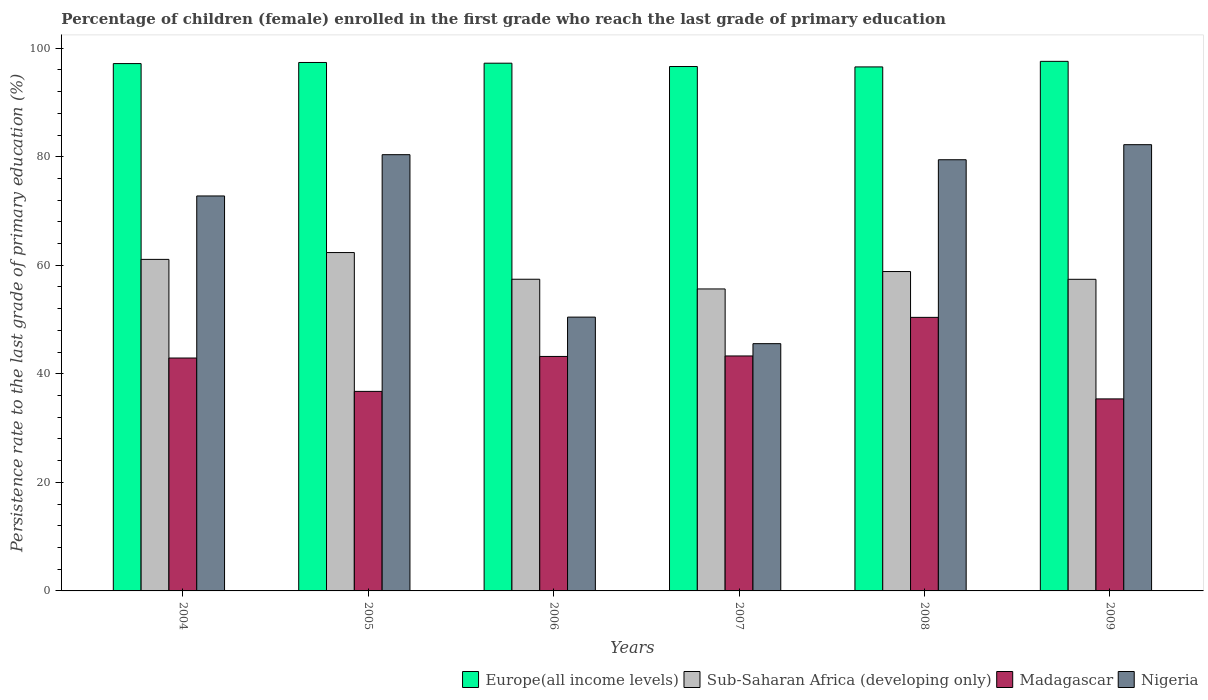How many different coloured bars are there?
Provide a succinct answer. 4. Are the number of bars on each tick of the X-axis equal?
Provide a succinct answer. Yes. What is the persistence rate of children in Sub-Saharan Africa (developing only) in 2009?
Provide a short and direct response. 57.41. Across all years, what is the maximum persistence rate of children in Europe(all income levels)?
Give a very brief answer. 97.57. Across all years, what is the minimum persistence rate of children in Sub-Saharan Africa (developing only)?
Your answer should be compact. 55.64. In which year was the persistence rate of children in Nigeria minimum?
Offer a terse response. 2007. What is the total persistence rate of children in Sub-Saharan Africa (developing only) in the graph?
Your answer should be very brief. 352.75. What is the difference between the persistence rate of children in Sub-Saharan Africa (developing only) in 2004 and that in 2009?
Make the answer very short. 3.67. What is the difference between the persistence rate of children in Europe(all income levels) in 2007 and the persistence rate of children in Nigeria in 2005?
Ensure brevity in your answer.  16.24. What is the average persistence rate of children in Sub-Saharan Africa (developing only) per year?
Make the answer very short. 58.79. In the year 2008, what is the difference between the persistence rate of children in Sub-Saharan Africa (developing only) and persistence rate of children in Nigeria?
Offer a very short reply. -20.6. What is the ratio of the persistence rate of children in Europe(all income levels) in 2005 to that in 2007?
Your response must be concise. 1.01. Is the persistence rate of children in Sub-Saharan Africa (developing only) in 2004 less than that in 2008?
Your response must be concise. No. Is the difference between the persistence rate of children in Sub-Saharan Africa (developing only) in 2005 and 2008 greater than the difference between the persistence rate of children in Nigeria in 2005 and 2008?
Your response must be concise. Yes. What is the difference between the highest and the second highest persistence rate of children in Europe(all income levels)?
Keep it short and to the point. 0.21. What is the difference between the highest and the lowest persistence rate of children in Sub-Saharan Africa (developing only)?
Provide a succinct answer. 6.71. In how many years, is the persistence rate of children in Nigeria greater than the average persistence rate of children in Nigeria taken over all years?
Keep it short and to the point. 4. Is the sum of the persistence rate of children in Europe(all income levels) in 2004 and 2008 greater than the maximum persistence rate of children in Nigeria across all years?
Ensure brevity in your answer.  Yes. Is it the case that in every year, the sum of the persistence rate of children in Madagascar and persistence rate of children in Europe(all income levels) is greater than the sum of persistence rate of children in Nigeria and persistence rate of children in Sub-Saharan Africa (developing only)?
Give a very brief answer. No. What does the 2nd bar from the left in 2004 represents?
Keep it short and to the point. Sub-Saharan Africa (developing only). What does the 1st bar from the right in 2006 represents?
Your answer should be compact. Nigeria. Is it the case that in every year, the sum of the persistence rate of children in Sub-Saharan Africa (developing only) and persistence rate of children in Nigeria is greater than the persistence rate of children in Madagascar?
Provide a succinct answer. Yes. How many bars are there?
Keep it short and to the point. 24. How many years are there in the graph?
Your answer should be compact. 6. What is the difference between two consecutive major ticks on the Y-axis?
Your response must be concise. 20. Are the values on the major ticks of Y-axis written in scientific E-notation?
Make the answer very short. No. Does the graph contain any zero values?
Give a very brief answer. No. How are the legend labels stacked?
Keep it short and to the point. Horizontal. What is the title of the graph?
Give a very brief answer. Percentage of children (female) enrolled in the first grade who reach the last grade of primary education. Does "Kuwait" appear as one of the legend labels in the graph?
Ensure brevity in your answer.  No. What is the label or title of the X-axis?
Provide a succinct answer. Years. What is the label or title of the Y-axis?
Give a very brief answer. Persistence rate to the last grade of primary education (%). What is the Persistence rate to the last grade of primary education (%) in Europe(all income levels) in 2004?
Your answer should be very brief. 97.16. What is the Persistence rate to the last grade of primary education (%) of Sub-Saharan Africa (developing only) in 2004?
Your response must be concise. 61.08. What is the Persistence rate to the last grade of primary education (%) of Madagascar in 2004?
Provide a short and direct response. 42.91. What is the Persistence rate to the last grade of primary education (%) in Nigeria in 2004?
Ensure brevity in your answer.  72.77. What is the Persistence rate to the last grade of primary education (%) of Europe(all income levels) in 2005?
Keep it short and to the point. 97.36. What is the Persistence rate to the last grade of primary education (%) of Sub-Saharan Africa (developing only) in 2005?
Offer a terse response. 62.34. What is the Persistence rate to the last grade of primary education (%) of Madagascar in 2005?
Ensure brevity in your answer.  36.77. What is the Persistence rate to the last grade of primary education (%) in Nigeria in 2005?
Provide a short and direct response. 80.38. What is the Persistence rate to the last grade of primary education (%) in Europe(all income levels) in 2006?
Keep it short and to the point. 97.23. What is the Persistence rate to the last grade of primary education (%) of Sub-Saharan Africa (developing only) in 2006?
Offer a very short reply. 57.43. What is the Persistence rate to the last grade of primary education (%) of Madagascar in 2006?
Provide a short and direct response. 43.2. What is the Persistence rate to the last grade of primary education (%) of Nigeria in 2006?
Offer a terse response. 50.45. What is the Persistence rate to the last grade of primary education (%) of Europe(all income levels) in 2007?
Ensure brevity in your answer.  96.62. What is the Persistence rate to the last grade of primary education (%) of Sub-Saharan Africa (developing only) in 2007?
Your answer should be compact. 55.64. What is the Persistence rate to the last grade of primary education (%) in Madagascar in 2007?
Provide a succinct answer. 43.29. What is the Persistence rate to the last grade of primary education (%) of Nigeria in 2007?
Your answer should be very brief. 45.56. What is the Persistence rate to the last grade of primary education (%) of Europe(all income levels) in 2008?
Provide a short and direct response. 96.55. What is the Persistence rate to the last grade of primary education (%) in Sub-Saharan Africa (developing only) in 2008?
Offer a very short reply. 58.85. What is the Persistence rate to the last grade of primary education (%) in Madagascar in 2008?
Offer a very short reply. 50.4. What is the Persistence rate to the last grade of primary education (%) in Nigeria in 2008?
Provide a short and direct response. 79.44. What is the Persistence rate to the last grade of primary education (%) in Europe(all income levels) in 2009?
Offer a very short reply. 97.57. What is the Persistence rate to the last grade of primary education (%) in Sub-Saharan Africa (developing only) in 2009?
Your answer should be compact. 57.41. What is the Persistence rate to the last grade of primary education (%) of Madagascar in 2009?
Provide a succinct answer. 35.38. What is the Persistence rate to the last grade of primary education (%) of Nigeria in 2009?
Keep it short and to the point. 82.22. Across all years, what is the maximum Persistence rate to the last grade of primary education (%) of Europe(all income levels)?
Offer a terse response. 97.57. Across all years, what is the maximum Persistence rate to the last grade of primary education (%) in Sub-Saharan Africa (developing only)?
Your answer should be compact. 62.34. Across all years, what is the maximum Persistence rate to the last grade of primary education (%) of Madagascar?
Give a very brief answer. 50.4. Across all years, what is the maximum Persistence rate to the last grade of primary education (%) of Nigeria?
Your response must be concise. 82.22. Across all years, what is the minimum Persistence rate to the last grade of primary education (%) of Europe(all income levels)?
Your response must be concise. 96.55. Across all years, what is the minimum Persistence rate to the last grade of primary education (%) of Sub-Saharan Africa (developing only)?
Your response must be concise. 55.64. Across all years, what is the minimum Persistence rate to the last grade of primary education (%) in Madagascar?
Your answer should be very brief. 35.38. Across all years, what is the minimum Persistence rate to the last grade of primary education (%) of Nigeria?
Provide a short and direct response. 45.56. What is the total Persistence rate to the last grade of primary education (%) in Europe(all income levels) in the graph?
Offer a very short reply. 582.49. What is the total Persistence rate to the last grade of primary education (%) of Sub-Saharan Africa (developing only) in the graph?
Your answer should be compact. 352.75. What is the total Persistence rate to the last grade of primary education (%) in Madagascar in the graph?
Make the answer very short. 251.95. What is the total Persistence rate to the last grade of primary education (%) of Nigeria in the graph?
Keep it short and to the point. 410.82. What is the difference between the Persistence rate to the last grade of primary education (%) in Europe(all income levels) in 2004 and that in 2005?
Keep it short and to the point. -0.2. What is the difference between the Persistence rate to the last grade of primary education (%) of Sub-Saharan Africa (developing only) in 2004 and that in 2005?
Make the answer very short. -1.26. What is the difference between the Persistence rate to the last grade of primary education (%) of Madagascar in 2004 and that in 2005?
Provide a succinct answer. 6.15. What is the difference between the Persistence rate to the last grade of primary education (%) in Nigeria in 2004 and that in 2005?
Offer a terse response. -7.61. What is the difference between the Persistence rate to the last grade of primary education (%) in Europe(all income levels) in 2004 and that in 2006?
Your response must be concise. -0.07. What is the difference between the Persistence rate to the last grade of primary education (%) in Sub-Saharan Africa (developing only) in 2004 and that in 2006?
Offer a terse response. 3.66. What is the difference between the Persistence rate to the last grade of primary education (%) of Madagascar in 2004 and that in 2006?
Give a very brief answer. -0.29. What is the difference between the Persistence rate to the last grade of primary education (%) of Nigeria in 2004 and that in 2006?
Provide a short and direct response. 22.32. What is the difference between the Persistence rate to the last grade of primary education (%) in Europe(all income levels) in 2004 and that in 2007?
Your answer should be compact. 0.54. What is the difference between the Persistence rate to the last grade of primary education (%) in Sub-Saharan Africa (developing only) in 2004 and that in 2007?
Offer a terse response. 5.45. What is the difference between the Persistence rate to the last grade of primary education (%) of Madagascar in 2004 and that in 2007?
Your answer should be compact. -0.38. What is the difference between the Persistence rate to the last grade of primary education (%) in Nigeria in 2004 and that in 2007?
Give a very brief answer. 27.21. What is the difference between the Persistence rate to the last grade of primary education (%) of Europe(all income levels) in 2004 and that in 2008?
Offer a terse response. 0.61. What is the difference between the Persistence rate to the last grade of primary education (%) of Sub-Saharan Africa (developing only) in 2004 and that in 2008?
Offer a terse response. 2.24. What is the difference between the Persistence rate to the last grade of primary education (%) of Madagascar in 2004 and that in 2008?
Make the answer very short. -7.49. What is the difference between the Persistence rate to the last grade of primary education (%) in Nigeria in 2004 and that in 2008?
Offer a terse response. -6.67. What is the difference between the Persistence rate to the last grade of primary education (%) of Europe(all income levels) in 2004 and that in 2009?
Give a very brief answer. -0.41. What is the difference between the Persistence rate to the last grade of primary education (%) in Sub-Saharan Africa (developing only) in 2004 and that in 2009?
Ensure brevity in your answer.  3.67. What is the difference between the Persistence rate to the last grade of primary education (%) in Madagascar in 2004 and that in 2009?
Offer a very short reply. 7.53. What is the difference between the Persistence rate to the last grade of primary education (%) in Nigeria in 2004 and that in 2009?
Make the answer very short. -9.45. What is the difference between the Persistence rate to the last grade of primary education (%) of Europe(all income levels) in 2005 and that in 2006?
Offer a terse response. 0.13. What is the difference between the Persistence rate to the last grade of primary education (%) in Sub-Saharan Africa (developing only) in 2005 and that in 2006?
Ensure brevity in your answer.  4.92. What is the difference between the Persistence rate to the last grade of primary education (%) in Madagascar in 2005 and that in 2006?
Provide a short and direct response. -6.43. What is the difference between the Persistence rate to the last grade of primary education (%) of Nigeria in 2005 and that in 2006?
Your answer should be compact. 29.93. What is the difference between the Persistence rate to the last grade of primary education (%) in Europe(all income levels) in 2005 and that in 2007?
Ensure brevity in your answer.  0.75. What is the difference between the Persistence rate to the last grade of primary education (%) in Sub-Saharan Africa (developing only) in 2005 and that in 2007?
Give a very brief answer. 6.71. What is the difference between the Persistence rate to the last grade of primary education (%) of Madagascar in 2005 and that in 2007?
Provide a short and direct response. -6.53. What is the difference between the Persistence rate to the last grade of primary education (%) in Nigeria in 2005 and that in 2007?
Make the answer very short. 34.82. What is the difference between the Persistence rate to the last grade of primary education (%) in Europe(all income levels) in 2005 and that in 2008?
Make the answer very short. 0.82. What is the difference between the Persistence rate to the last grade of primary education (%) in Sub-Saharan Africa (developing only) in 2005 and that in 2008?
Offer a very short reply. 3.5. What is the difference between the Persistence rate to the last grade of primary education (%) in Madagascar in 2005 and that in 2008?
Ensure brevity in your answer.  -13.64. What is the difference between the Persistence rate to the last grade of primary education (%) in Nigeria in 2005 and that in 2008?
Your response must be concise. 0.93. What is the difference between the Persistence rate to the last grade of primary education (%) of Europe(all income levels) in 2005 and that in 2009?
Make the answer very short. -0.21. What is the difference between the Persistence rate to the last grade of primary education (%) in Sub-Saharan Africa (developing only) in 2005 and that in 2009?
Your answer should be very brief. 4.93. What is the difference between the Persistence rate to the last grade of primary education (%) in Madagascar in 2005 and that in 2009?
Give a very brief answer. 1.39. What is the difference between the Persistence rate to the last grade of primary education (%) of Nigeria in 2005 and that in 2009?
Give a very brief answer. -1.84. What is the difference between the Persistence rate to the last grade of primary education (%) of Europe(all income levels) in 2006 and that in 2007?
Ensure brevity in your answer.  0.61. What is the difference between the Persistence rate to the last grade of primary education (%) of Sub-Saharan Africa (developing only) in 2006 and that in 2007?
Give a very brief answer. 1.79. What is the difference between the Persistence rate to the last grade of primary education (%) of Madagascar in 2006 and that in 2007?
Offer a very short reply. -0.09. What is the difference between the Persistence rate to the last grade of primary education (%) of Nigeria in 2006 and that in 2007?
Your answer should be very brief. 4.89. What is the difference between the Persistence rate to the last grade of primary education (%) in Europe(all income levels) in 2006 and that in 2008?
Your answer should be compact. 0.68. What is the difference between the Persistence rate to the last grade of primary education (%) of Sub-Saharan Africa (developing only) in 2006 and that in 2008?
Your response must be concise. -1.42. What is the difference between the Persistence rate to the last grade of primary education (%) of Madagascar in 2006 and that in 2008?
Offer a terse response. -7.2. What is the difference between the Persistence rate to the last grade of primary education (%) in Nigeria in 2006 and that in 2008?
Offer a very short reply. -29. What is the difference between the Persistence rate to the last grade of primary education (%) in Europe(all income levels) in 2006 and that in 2009?
Ensure brevity in your answer.  -0.34. What is the difference between the Persistence rate to the last grade of primary education (%) of Sub-Saharan Africa (developing only) in 2006 and that in 2009?
Your answer should be very brief. 0.01. What is the difference between the Persistence rate to the last grade of primary education (%) in Madagascar in 2006 and that in 2009?
Offer a terse response. 7.82. What is the difference between the Persistence rate to the last grade of primary education (%) in Nigeria in 2006 and that in 2009?
Provide a short and direct response. -31.77. What is the difference between the Persistence rate to the last grade of primary education (%) of Europe(all income levels) in 2007 and that in 2008?
Make the answer very short. 0.07. What is the difference between the Persistence rate to the last grade of primary education (%) in Sub-Saharan Africa (developing only) in 2007 and that in 2008?
Give a very brief answer. -3.21. What is the difference between the Persistence rate to the last grade of primary education (%) in Madagascar in 2007 and that in 2008?
Your answer should be very brief. -7.11. What is the difference between the Persistence rate to the last grade of primary education (%) in Nigeria in 2007 and that in 2008?
Keep it short and to the point. -33.89. What is the difference between the Persistence rate to the last grade of primary education (%) in Europe(all income levels) in 2007 and that in 2009?
Keep it short and to the point. -0.95. What is the difference between the Persistence rate to the last grade of primary education (%) of Sub-Saharan Africa (developing only) in 2007 and that in 2009?
Your answer should be compact. -1.78. What is the difference between the Persistence rate to the last grade of primary education (%) of Madagascar in 2007 and that in 2009?
Your answer should be compact. 7.91. What is the difference between the Persistence rate to the last grade of primary education (%) of Nigeria in 2007 and that in 2009?
Offer a terse response. -36.66. What is the difference between the Persistence rate to the last grade of primary education (%) in Europe(all income levels) in 2008 and that in 2009?
Provide a succinct answer. -1.02. What is the difference between the Persistence rate to the last grade of primary education (%) in Sub-Saharan Africa (developing only) in 2008 and that in 2009?
Offer a terse response. 1.43. What is the difference between the Persistence rate to the last grade of primary education (%) of Madagascar in 2008 and that in 2009?
Provide a succinct answer. 15.02. What is the difference between the Persistence rate to the last grade of primary education (%) in Nigeria in 2008 and that in 2009?
Make the answer very short. -2.77. What is the difference between the Persistence rate to the last grade of primary education (%) of Europe(all income levels) in 2004 and the Persistence rate to the last grade of primary education (%) of Sub-Saharan Africa (developing only) in 2005?
Your answer should be compact. 34.82. What is the difference between the Persistence rate to the last grade of primary education (%) in Europe(all income levels) in 2004 and the Persistence rate to the last grade of primary education (%) in Madagascar in 2005?
Offer a terse response. 60.4. What is the difference between the Persistence rate to the last grade of primary education (%) in Europe(all income levels) in 2004 and the Persistence rate to the last grade of primary education (%) in Nigeria in 2005?
Your answer should be compact. 16.78. What is the difference between the Persistence rate to the last grade of primary education (%) in Sub-Saharan Africa (developing only) in 2004 and the Persistence rate to the last grade of primary education (%) in Madagascar in 2005?
Provide a short and direct response. 24.32. What is the difference between the Persistence rate to the last grade of primary education (%) in Sub-Saharan Africa (developing only) in 2004 and the Persistence rate to the last grade of primary education (%) in Nigeria in 2005?
Provide a short and direct response. -19.29. What is the difference between the Persistence rate to the last grade of primary education (%) in Madagascar in 2004 and the Persistence rate to the last grade of primary education (%) in Nigeria in 2005?
Offer a very short reply. -37.47. What is the difference between the Persistence rate to the last grade of primary education (%) in Europe(all income levels) in 2004 and the Persistence rate to the last grade of primary education (%) in Sub-Saharan Africa (developing only) in 2006?
Ensure brevity in your answer.  39.74. What is the difference between the Persistence rate to the last grade of primary education (%) in Europe(all income levels) in 2004 and the Persistence rate to the last grade of primary education (%) in Madagascar in 2006?
Offer a very short reply. 53.96. What is the difference between the Persistence rate to the last grade of primary education (%) in Europe(all income levels) in 2004 and the Persistence rate to the last grade of primary education (%) in Nigeria in 2006?
Make the answer very short. 46.71. What is the difference between the Persistence rate to the last grade of primary education (%) of Sub-Saharan Africa (developing only) in 2004 and the Persistence rate to the last grade of primary education (%) of Madagascar in 2006?
Offer a very short reply. 17.88. What is the difference between the Persistence rate to the last grade of primary education (%) of Sub-Saharan Africa (developing only) in 2004 and the Persistence rate to the last grade of primary education (%) of Nigeria in 2006?
Your answer should be very brief. 10.64. What is the difference between the Persistence rate to the last grade of primary education (%) in Madagascar in 2004 and the Persistence rate to the last grade of primary education (%) in Nigeria in 2006?
Make the answer very short. -7.54. What is the difference between the Persistence rate to the last grade of primary education (%) of Europe(all income levels) in 2004 and the Persistence rate to the last grade of primary education (%) of Sub-Saharan Africa (developing only) in 2007?
Your answer should be very brief. 41.52. What is the difference between the Persistence rate to the last grade of primary education (%) in Europe(all income levels) in 2004 and the Persistence rate to the last grade of primary education (%) in Madagascar in 2007?
Your answer should be compact. 53.87. What is the difference between the Persistence rate to the last grade of primary education (%) in Europe(all income levels) in 2004 and the Persistence rate to the last grade of primary education (%) in Nigeria in 2007?
Offer a very short reply. 51.6. What is the difference between the Persistence rate to the last grade of primary education (%) of Sub-Saharan Africa (developing only) in 2004 and the Persistence rate to the last grade of primary education (%) of Madagascar in 2007?
Your answer should be compact. 17.79. What is the difference between the Persistence rate to the last grade of primary education (%) of Sub-Saharan Africa (developing only) in 2004 and the Persistence rate to the last grade of primary education (%) of Nigeria in 2007?
Your answer should be very brief. 15.53. What is the difference between the Persistence rate to the last grade of primary education (%) in Madagascar in 2004 and the Persistence rate to the last grade of primary education (%) in Nigeria in 2007?
Make the answer very short. -2.65. What is the difference between the Persistence rate to the last grade of primary education (%) of Europe(all income levels) in 2004 and the Persistence rate to the last grade of primary education (%) of Sub-Saharan Africa (developing only) in 2008?
Make the answer very short. 38.32. What is the difference between the Persistence rate to the last grade of primary education (%) of Europe(all income levels) in 2004 and the Persistence rate to the last grade of primary education (%) of Madagascar in 2008?
Keep it short and to the point. 46.76. What is the difference between the Persistence rate to the last grade of primary education (%) in Europe(all income levels) in 2004 and the Persistence rate to the last grade of primary education (%) in Nigeria in 2008?
Keep it short and to the point. 17.72. What is the difference between the Persistence rate to the last grade of primary education (%) in Sub-Saharan Africa (developing only) in 2004 and the Persistence rate to the last grade of primary education (%) in Madagascar in 2008?
Provide a short and direct response. 10.68. What is the difference between the Persistence rate to the last grade of primary education (%) of Sub-Saharan Africa (developing only) in 2004 and the Persistence rate to the last grade of primary education (%) of Nigeria in 2008?
Ensure brevity in your answer.  -18.36. What is the difference between the Persistence rate to the last grade of primary education (%) of Madagascar in 2004 and the Persistence rate to the last grade of primary education (%) of Nigeria in 2008?
Provide a short and direct response. -36.53. What is the difference between the Persistence rate to the last grade of primary education (%) in Europe(all income levels) in 2004 and the Persistence rate to the last grade of primary education (%) in Sub-Saharan Africa (developing only) in 2009?
Your response must be concise. 39.75. What is the difference between the Persistence rate to the last grade of primary education (%) in Europe(all income levels) in 2004 and the Persistence rate to the last grade of primary education (%) in Madagascar in 2009?
Offer a very short reply. 61.78. What is the difference between the Persistence rate to the last grade of primary education (%) in Europe(all income levels) in 2004 and the Persistence rate to the last grade of primary education (%) in Nigeria in 2009?
Your response must be concise. 14.94. What is the difference between the Persistence rate to the last grade of primary education (%) of Sub-Saharan Africa (developing only) in 2004 and the Persistence rate to the last grade of primary education (%) of Madagascar in 2009?
Ensure brevity in your answer.  25.71. What is the difference between the Persistence rate to the last grade of primary education (%) of Sub-Saharan Africa (developing only) in 2004 and the Persistence rate to the last grade of primary education (%) of Nigeria in 2009?
Keep it short and to the point. -21.14. What is the difference between the Persistence rate to the last grade of primary education (%) in Madagascar in 2004 and the Persistence rate to the last grade of primary education (%) in Nigeria in 2009?
Offer a very short reply. -39.31. What is the difference between the Persistence rate to the last grade of primary education (%) in Europe(all income levels) in 2005 and the Persistence rate to the last grade of primary education (%) in Sub-Saharan Africa (developing only) in 2006?
Offer a very short reply. 39.94. What is the difference between the Persistence rate to the last grade of primary education (%) of Europe(all income levels) in 2005 and the Persistence rate to the last grade of primary education (%) of Madagascar in 2006?
Your answer should be compact. 54.16. What is the difference between the Persistence rate to the last grade of primary education (%) of Europe(all income levels) in 2005 and the Persistence rate to the last grade of primary education (%) of Nigeria in 2006?
Your answer should be very brief. 46.92. What is the difference between the Persistence rate to the last grade of primary education (%) of Sub-Saharan Africa (developing only) in 2005 and the Persistence rate to the last grade of primary education (%) of Madagascar in 2006?
Provide a succinct answer. 19.14. What is the difference between the Persistence rate to the last grade of primary education (%) of Sub-Saharan Africa (developing only) in 2005 and the Persistence rate to the last grade of primary education (%) of Nigeria in 2006?
Ensure brevity in your answer.  11.89. What is the difference between the Persistence rate to the last grade of primary education (%) in Madagascar in 2005 and the Persistence rate to the last grade of primary education (%) in Nigeria in 2006?
Provide a short and direct response. -13.68. What is the difference between the Persistence rate to the last grade of primary education (%) of Europe(all income levels) in 2005 and the Persistence rate to the last grade of primary education (%) of Sub-Saharan Africa (developing only) in 2007?
Your response must be concise. 41.73. What is the difference between the Persistence rate to the last grade of primary education (%) in Europe(all income levels) in 2005 and the Persistence rate to the last grade of primary education (%) in Madagascar in 2007?
Provide a short and direct response. 54.07. What is the difference between the Persistence rate to the last grade of primary education (%) of Europe(all income levels) in 2005 and the Persistence rate to the last grade of primary education (%) of Nigeria in 2007?
Your answer should be compact. 51.81. What is the difference between the Persistence rate to the last grade of primary education (%) of Sub-Saharan Africa (developing only) in 2005 and the Persistence rate to the last grade of primary education (%) of Madagascar in 2007?
Your answer should be very brief. 19.05. What is the difference between the Persistence rate to the last grade of primary education (%) of Sub-Saharan Africa (developing only) in 2005 and the Persistence rate to the last grade of primary education (%) of Nigeria in 2007?
Keep it short and to the point. 16.79. What is the difference between the Persistence rate to the last grade of primary education (%) in Madagascar in 2005 and the Persistence rate to the last grade of primary education (%) in Nigeria in 2007?
Offer a terse response. -8.79. What is the difference between the Persistence rate to the last grade of primary education (%) in Europe(all income levels) in 2005 and the Persistence rate to the last grade of primary education (%) in Sub-Saharan Africa (developing only) in 2008?
Provide a short and direct response. 38.52. What is the difference between the Persistence rate to the last grade of primary education (%) in Europe(all income levels) in 2005 and the Persistence rate to the last grade of primary education (%) in Madagascar in 2008?
Give a very brief answer. 46.96. What is the difference between the Persistence rate to the last grade of primary education (%) in Europe(all income levels) in 2005 and the Persistence rate to the last grade of primary education (%) in Nigeria in 2008?
Your answer should be compact. 17.92. What is the difference between the Persistence rate to the last grade of primary education (%) of Sub-Saharan Africa (developing only) in 2005 and the Persistence rate to the last grade of primary education (%) of Madagascar in 2008?
Your response must be concise. 11.94. What is the difference between the Persistence rate to the last grade of primary education (%) in Sub-Saharan Africa (developing only) in 2005 and the Persistence rate to the last grade of primary education (%) in Nigeria in 2008?
Your answer should be compact. -17.1. What is the difference between the Persistence rate to the last grade of primary education (%) of Madagascar in 2005 and the Persistence rate to the last grade of primary education (%) of Nigeria in 2008?
Offer a terse response. -42.68. What is the difference between the Persistence rate to the last grade of primary education (%) of Europe(all income levels) in 2005 and the Persistence rate to the last grade of primary education (%) of Sub-Saharan Africa (developing only) in 2009?
Your answer should be compact. 39.95. What is the difference between the Persistence rate to the last grade of primary education (%) of Europe(all income levels) in 2005 and the Persistence rate to the last grade of primary education (%) of Madagascar in 2009?
Give a very brief answer. 61.98. What is the difference between the Persistence rate to the last grade of primary education (%) of Europe(all income levels) in 2005 and the Persistence rate to the last grade of primary education (%) of Nigeria in 2009?
Make the answer very short. 15.14. What is the difference between the Persistence rate to the last grade of primary education (%) in Sub-Saharan Africa (developing only) in 2005 and the Persistence rate to the last grade of primary education (%) in Madagascar in 2009?
Give a very brief answer. 26.96. What is the difference between the Persistence rate to the last grade of primary education (%) of Sub-Saharan Africa (developing only) in 2005 and the Persistence rate to the last grade of primary education (%) of Nigeria in 2009?
Make the answer very short. -19.88. What is the difference between the Persistence rate to the last grade of primary education (%) in Madagascar in 2005 and the Persistence rate to the last grade of primary education (%) in Nigeria in 2009?
Offer a terse response. -45.45. What is the difference between the Persistence rate to the last grade of primary education (%) of Europe(all income levels) in 2006 and the Persistence rate to the last grade of primary education (%) of Sub-Saharan Africa (developing only) in 2007?
Provide a short and direct response. 41.59. What is the difference between the Persistence rate to the last grade of primary education (%) of Europe(all income levels) in 2006 and the Persistence rate to the last grade of primary education (%) of Madagascar in 2007?
Ensure brevity in your answer.  53.94. What is the difference between the Persistence rate to the last grade of primary education (%) in Europe(all income levels) in 2006 and the Persistence rate to the last grade of primary education (%) in Nigeria in 2007?
Your response must be concise. 51.67. What is the difference between the Persistence rate to the last grade of primary education (%) of Sub-Saharan Africa (developing only) in 2006 and the Persistence rate to the last grade of primary education (%) of Madagascar in 2007?
Provide a short and direct response. 14.13. What is the difference between the Persistence rate to the last grade of primary education (%) of Sub-Saharan Africa (developing only) in 2006 and the Persistence rate to the last grade of primary education (%) of Nigeria in 2007?
Your response must be concise. 11.87. What is the difference between the Persistence rate to the last grade of primary education (%) in Madagascar in 2006 and the Persistence rate to the last grade of primary education (%) in Nigeria in 2007?
Your response must be concise. -2.36. What is the difference between the Persistence rate to the last grade of primary education (%) in Europe(all income levels) in 2006 and the Persistence rate to the last grade of primary education (%) in Sub-Saharan Africa (developing only) in 2008?
Your response must be concise. 38.39. What is the difference between the Persistence rate to the last grade of primary education (%) of Europe(all income levels) in 2006 and the Persistence rate to the last grade of primary education (%) of Madagascar in 2008?
Your response must be concise. 46.83. What is the difference between the Persistence rate to the last grade of primary education (%) of Europe(all income levels) in 2006 and the Persistence rate to the last grade of primary education (%) of Nigeria in 2008?
Offer a terse response. 17.79. What is the difference between the Persistence rate to the last grade of primary education (%) of Sub-Saharan Africa (developing only) in 2006 and the Persistence rate to the last grade of primary education (%) of Madagascar in 2008?
Your response must be concise. 7.02. What is the difference between the Persistence rate to the last grade of primary education (%) of Sub-Saharan Africa (developing only) in 2006 and the Persistence rate to the last grade of primary education (%) of Nigeria in 2008?
Provide a succinct answer. -22.02. What is the difference between the Persistence rate to the last grade of primary education (%) in Madagascar in 2006 and the Persistence rate to the last grade of primary education (%) in Nigeria in 2008?
Ensure brevity in your answer.  -36.24. What is the difference between the Persistence rate to the last grade of primary education (%) of Europe(all income levels) in 2006 and the Persistence rate to the last grade of primary education (%) of Sub-Saharan Africa (developing only) in 2009?
Provide a short and direct response. 39.82. What is the difference between the Persistence rate to the last grade of primary education (%) of Europe(all income levels) in 2006 and the Persistence rate to the last grade of primary education (%) of Madagascar in 2009?
Ensure brevity in your answer.  61.85. What is the difference between the Persistence rate to the last grade of primary education (%) of Europe(all income levels) in 2006 and the Persistence rate to the last grade of primary education (%) of Nigeria in 2009?
Give a very brief answer. 15.01. What is the difference between the Persistence rate to the last grade of primary education (%) in Sub-Saharan Africa (developing only) in 2006 and the Persistence rate to the last grade of primary education (%) in Madagascar in 2009?
Your response must be concise. 22.05. What is the difference between the Persistence rate to the last grade of primary education (%) of Sub-Saharan Africa (developing only) in 2006 and the Persistence rate to the last grade of primary education (%) of Nigeria in 2009?
Your answer should be compact. -24.79. What is the difference between the Persistence rate to the last grade of primary education (%) in Madagascar in 2006 and the Persistence rate to the last grade of primary education (%) in Nigeria in 2009?
Your response must be concise. -39.02. What is the difference between the Persistence rate to the last grade of primary education (%) in Europe(all income levels) in 2007 and the Persistence rate to the last grade of primary education (%) in Sub-Saharan Africa (developing only) in 2008?
Provide a succinct answer. 37.77. What is the difference between the Persistence rate to the last grade of primary education (%) of Europe(all income levels) in 2007 and the Persistence rate to the last grade of primary education (%) of Madagascar in 2008?
Offer a very short reply. 46.22. What is the difference between the Persistence rate to the last grade of primary education (%) in Europe(all income levels) in 2007 and the Persistence rate to the last grade of primary education (%) in Nigeria in 2008?
Make the answer very short. 17.17. What is the difference between the Persistence rate to the last grade of primary education (%) of Sub-Saharan Africa (developing only) in 2007 and the Persistence rate to the last grade of primary education (%) of Madagascar in 2008?
Ensure brevity in your answer.  5.24. What is the difference between the Persistence rate to the last grade of primary education (%) in Sub-Saharan Africa (developing only) in 2007 and the Persistence rate to the last grade of primary education (%) in Nigeria in 2008?
Keep it short and to the point. -23.81. What is the difference between the Persistence rate to the last grade of primary education (%) in Madagascar in 2007 and the Persistence rate to the last grade of primary education (%) in Nigeria in 2008?
Keep it short and to the point. -36.15. What is the difference between the Persistence rate to the last grade of primary education (%) of Europe(all income levels) in 2007 and the Persistence rate to the last grade of primary education (%) of Sub-Saharan Africa (developing only) in 2009?
Your response must be concise. 39.2. What is the difference between the Persistence rate to the last grade of primary education (%) of Europe(all income levels) in 2007 and the Persistence rate to the last grade of primary education (%) of Madagascar in 2009?
Your answer should be compact. 61.24. What is the difference between the Persistence rate to the last grade of primary education (%) in Europe(all income levels) in 2007 and the Persistence rate to the last grade of primary education (%) in Nigeria in 2009?
Ensure brevity in your answer.  14.4. What is the difference between the Persistence rate to the last grade of primary education (%) in Sub-Saharan Africa (developing only) in 2007 and the Persistence rate to the last grade of primary education (%) in Madagascar in 2009?
Provide a succinct answer. 20.26. What is the difference between the Persistence rate to the last grade of primary education (%) of Sub-Saharan Africa (developing only) in 2007 and the Persistence rate to the last grade of primary education (%) of Nigeria in 2009?
Make the answer very short. -26.58. What is the difference between the Persistence rate to the last grade of primary education (%) in Madagascar in 2007 and the Persistence rate to the last grade of primary education (%) in Nigeria in 2009?
Ensure brevity in your answer.  -38.93. What is the difference between the Persistence rate to the last grade of primary education (%) of Europe(all income levels) in 2008 and the Persistence rate to the last grade of primary education (%) of Sub-Saharan Africa (developing only) in 2009?
Your answer should be compact. 39.13. What is the difference between the Persistence rate to the last grade of primary education (%) of Europe(all income levels) in 2008 and the Persistence rate to the last grade of primary education (%) of Madagascar in 2009?
Ensure brevity in your answer.  61.17. What is the difference between the Persistence rate to the last grade of primary education (%) in Europe(all income levels) in 2008 and the Persistence rate to the last grade of primary education (%) in Nigeria in 2009?
Keep it short and to the point. 14.33. What is the difference between the Persistence rate to the last grade of primary education (%) in Sub-Saharan Africa (developing only) in 2008 and the Persistence rate to the last grade of primary education (%) in Madagascar in 2009?
Provide a succinct answer. 23.47. What is the difference between the Persistence rate to the last grade of primary education (%) in Sub-Saharan Africa (developing only) in 2008 and the Persistence rate to the last grade of primary education (%) in Nigeria in 2009?
Keep it short and to the point. -23.37. What is the difference between the Persistence rate to the last grade of primary education (%) of Madagascar in 2008 and the Persistence rate to the last grade of primary education (%) of Nigeria in 2009?
Keep it short and to the point. -31.82. What is the average Persistence rate to the last grade of primary education (%) in Europe(all income levels) per year?
Offer a terse response. 97.08. What is the average Persistence rate to the last grade of primary education (%) in Sub-Saharan Africa (developing only) per year?
Your answer should be very brief. 58.79. What is the average Persistence rate to the last grade of primary education (%) of Madagascar per year?
Your answer should be very brief. 41.99. What is the average Persistence rate to the last grade of primary education (%) in Nigeria per year?
Your answer should be compact. 68.47. In the year 2004, what is the difference between the Persistence rate to the last grade of primary education (%) of Europe(all income levels) and Persistence rate to the last grade of primary education (%) of Sub-Saharan Africa (developing only)?
Provide a succinct answer. 36.08. In the year 2004, what is the difference between the Persistence rate to the last grade of primary education (%) in Europe(all income levels) and Persistence rate to the last grade of primary education (%) in Madagascar?
Offer a terse response. 54.25. In the year 2004, what is the difference between the Persistence rate to the last grade of primary education (%) in Europe(all income levels) and Persistence rate to the last grade of primary education (%) in Nigeria?
Provide a succinct answer. 24.39. In the year 2004, what is the difference between the Persistence rate to the last grade of primary education (%) of Sub-Saharan Africa (developing only) and Persistence rate to the last grade of primary education (%) of Madagascar?
Make the answer very short. 18.17. In the year 2004, what is the difference between the Persistence rate to the last grade of primary education (%) in Sub-Saharan Africa (developing only) and Persistence rate to the last grade of primary education (%) in Nigeria?
Offer a terse response. -11.69. In the year 2004, what is the difference between the Persistence rate to the last grade of primary education (%) in Madagascar and Persistence rate to the last grade of primary education (%) in Nigeria?
Your answer should be very brief. -29.86. In the year 2005, what is the difference between the Persistence rate to the last grade of primary education (%) of Europe(all income levels) and Persistence rate to the last grade of primary education (%) of Sub-Saharan Africa (developing only)?
Offer a terse response. 35.02. In the year 2005, what is the difference between the Persistence rate to the last grade of primary education (%) in Europe(all income levels) and Persistence rate to the last grade of primary education (%) in Madagascar?
Your response must be concise. 60.6. In the year 2005, what is the difference between the Persistence rate to the last grade of primary education (%) of Europe(all income levels) and Persistence rate to the last grade of primary education (%) of Nigeria?
Give a very brief answer. 16.99. In the year 2005, what is the difference between the Persistence rate to the last grade of primary education (%) of Sub-Saharan Africa (developing only) and Persistence rate to the last grade of primary education (%) of Madagascar?
Your answer should be compact. 25.58. In the year 2005, what is the difference between the Persistence rate to the last grade of primary education (%) of Sub-Saharan Africa (developing only) and Persistence rate to the last grade of primary education (%) of Nigeria?
Offer a very short reply. -18.03. In the year 2005, what is the difference between the Persistence rate to the last grade of primary education (%) of Madagascar and Persistence rate to the last grade of primary education (%) of Nigeria?
Your answer should be very brief. -43.61. In the year 2006, what is the difference between the Persistence rate to the last grade of primary education (%) of Europe(all income levels) and Persistence rate to the last grade of primary education (%) of Sub-Saharan Africa (developing only)?
Keep it short and to the point. 39.81. In the year 2006, what is the difference between the Persistence rate to the last grade of primary education (%) in Europe(all income levels) and Persistence rate to the last grade of primary education (%) in Madagascar?
Your response must be concise. 54.03. In the year 2006, what is the difference between the Persistence rate to the last grade of primary education (%) of Europe(all income levels) and Persistence rate to the last grade of primary education (%) of Nigeria?
Ensure brevity in your answer.  46.78. In the year 2006, what is the difference between the Persistence rate to the last grade of primary education (%) of Sub-Saharan Africa (developing only) and Persistence rate to the last grade of primary education (%) of Madagascar?
Keep it short and to the point. 14.22. In the year 2006, what is the difference between the Persistence rate to the last grade of primary education (%) in Sub-Saharan Africa (developing only) and Persistence rate to the last grade of primary education (%) in Nigeria?
Provide a succinct answer. 6.98. In the year 2006, what is the difference between the Persistence rate to the last grade of primary education (%) of Madagascar and Persistence rate to the last grade of primary education (%) of Nigeria?
Offer a terse response. -7.25. In the year 2007, what is the difference between the Persistence rate to the last grade of primary education (%) of Europe(all income levels) and Persistence rate to the last grade of primary education (%) of Sub-Saharan Africa (developing only)?
Offer a very short reply. 40.98. In the year 2007, what is the difference between the Persistence rate to the last grade of primary education (%) in Europe(all income levels) and Persistence rate to the last grade of primary education (%) in Madagascar?
Your response must be concise. 53.33. In the year 2007, what is the difference between the Persistence rate to the last grade of primary education (%) of Europe(all income levels) and Persistence rate to the last grade of primary education (%) of Nigeria?
Provide a succinct answer. 51.06. In the year 2007, what is the difference between the Persistence rate to the last grade of primary education (%) of Sub-Saharan Africa (developing only) and Persistence rate to the last grade of primary education (%) of Madagascar?
Provide a succinct answer. 12.35. In the year 2007, what is the difference between the Persistence rate to the last grade of primary education (%) of Sub-Saharan Africa (developing only) and Persistence rate to the last grade of primary education (%) of Nigeria?
Offer a very short reply. 10.08. In the year 2007, what is the difference between the Persistence rate to the last grade of primary education (%) of Madagascar and Persistence rate to the last grade of primary education (%) of Nigeria?
Your answer should be very brief. -2.27. In the year 2008, what is the difference between the Persistence rate to the last grade of primary education (%) in Europe(all income levels) and Persistence rate to the last grade of primary education (%) in Sub-Saharan Africa (developing only)?
Offer a terse response. 37.7. In the year 2008, what is the difference between the Persistence rate to the last grade of primary education (%) in Europe(all income levels) and Persistence rate to the last grade of primary education (%) in Madagascar?
Your answer should be compact. 46.15. In the year 2008, what is the difference between the Persistence rate to the last grade of primary education (%) of Europe(all income levels) and Persistence rate to the last grade of primary education (%) of Nigeria?
Your response must be concise. 17.1. In the year 2008, what is the difference between the Persistence rate to the last grade of primary education (%) in Sub-Saharan Africa (developing only) and Persistence rate to the last grade of primary education (%) in Madagascar?
Your answer should be very brief. 8.45. In the year 2008, what is the difference between the Persistence rate to the last grade of primary education (%) in Sub-Saharan Africa (developing only) and Persistence rate to the last grade of primary education (%) in Nigeria?
Your answer should be compact. -20.6. In the year 2008, what is the difference between the Persistence rate to the last grade of primary education (%) in Madagascar and Persistence rate to the last grade of primary education (%) in Nigeria?
Offer a terse response. -29.04. In the year 2009, what is the difference between the Persistence rate to the last grade of primary education (%) in Europe(all income levels) and Persistence rate to the last grade of primary education (%) in Sub-Saharan Africa (developing only)?
Offer a terse response. 40.16. In the year 2009, what is the difference between the Persistence rate to the last grade of primary education (%) of Europe(all income levels) and Persistence rate to the last grade of primary education (%) of Madagascar?
Offer a terse response. 62.19. In the year 2009, what is the difference between the Persistence rate to the last grade of primary education (%) of Europe(all income levels) and Persistence rate to the last grade of primary education (%) of Nigeria?
Your response must be concise. 15.35. In the year 2009, what is the difference between the Persistence rate to the last grade of primary education (%) in Sub-Saharan Africa (developing only) and Persistence rate to the last grade of primary education (%) in Madagascar?
Give a very brief answer. 22.03. In the year 2009, what is the difference between the Persistence rate to the last grade of primary education (%) of Sub-Saharan Africa (developing only) and Persistence rate to the last grade of primary education (%) of Nigeria?
Give a very brief answer. -24.81. In the year 2009, what is the difference between the Persistence rate to the last grade of primary education (%) in Madagascar and Persistence rate to the last grade of primary education (%) in Nigeria?
Your answer should be compact. -46.84. What is the ratio of the Persistence rate to the last grade of primary education (%) in Sub-Saharan Africa (developing only) in 2004 to that in 2005?
Ensure brevity in your answer.  0.98. What is the ratio of the Persistence rate to the last grade of primary education (%) of Madagascar in 2004 to that in 2005?
Provide a succinct answer. 1.17. What is the ratio of the Persistence rate to the last grade of primary education (%) of Nigeria in 2004 to that in 2005?
Your answer should be compact. 0.91. What is the ratio of the Persistence rate to the last grade of primary education (%) of Europe(all income levels) in 2004 to that in 2006?
Provide a succinct answer. 1. What is the ratio of the Persistence rate to the last grade of primary education (%) of Sub-Saharan Africa (developing only) in 2004 to that in 2006?
Offer a terse response. 1.06. What is the ratio of the Persistence rate to the last grade of primary education (%) in Nigeria in 2004 to that in 2006?
Make the answer very short. 1.44. What is the ratio of the Persistence rate to the last grade of primary education (%) in Europe(all income levels) in 2004 to that in 2007?
Give a very brief answer. 1.01. What is the ratio of the Persistence rate to the last grade of primary education (%) in Sub-Saharan Africa (developing only) in 2004 to that in 2007?
Your response must be concise. 1.1. What is the ratio of the Persistence rate to the last grade of primary education (%) in Madagascar in 2004 to that in 2007?
Offer a very short reply. 0.99. What is the ratio of the Persistence rate to the last grade of primary education (%) of Nigeria in 2004 to that in 2007?
Your response must be concise. 1.6. What is the ratio of the Persistence rate to the last grade of primary education (%) of Europe(all income levels) in 2004 to that in 2008?
Keep it short and to the point. 1.01. What is the ratio of the Persistence rate to the last grade of primary education (%) of Sub-Saharan Africa (developing only) in 2004 to that in 2008?
Offer a terse response. 1.04. What is the ratio of the Persistence rate to the last grade of primary education (%) of Madagascar in 2004 to that in 2008?
Your answer should be compact. 0.85. What is the ratio of the Persistence rate to the last grade of primary education (%) in Nigeria in 2004 to that in 2008?
Your answer should be very brief. 0.92. What is the ratio of the Persistence rate to the last grade of primary education (%) in Europe(all income levels) in 2004 to that in 2009?
Offer a very short reply. 1. What is the ratio of the Persistence rate to the last grade of primary education (%) of Sub-Saharan Africa (developing only) in 2004 to that in 2009?
Offer a terse response. 1.06. What is the ratio of the Persistence rate to the last grade of primary education (%) in Madagascar in 2004 to that in 2009?
Make the answer very short. 1.21. What is the ratio of the Persistence rate to the last grade of primary education (%) in Nigeria in 2004 to that in 2009?
Your answer should be compact. 0.89. What is the ratio of the Persistence rate to the last grade of primary education (%) in Sub-Saharan Africa (developing only) in 2005 to that in 2006?
Offer a very short reply. 1.09. What is the ratio of the Persistence rate to the last grade of primary education (%) in Madagascar in 2005 to that in 2006?
Offer a terse response. 0.85. What is the ratio of the Persistence rate to the last grade of primary education (%) of Nigeria in 2005 to that in 2006?
Your answer should be compact. 1.59. What is the ratio of the Persistence rate to the last grade of primary education (%) in Europe(all income levels) in 2005 to that in 2007?
Provide a succinct answer. 1.01. What is the ratio of the Persistence rate to the last grade of primary education (%) in Sub-Saharan Africa (developing only) in 2005 to that in 2007?
Offer a terse response. 1.12. What is the ratio of the Persistence rate to the last grade of primary education (%) in Madagascar in 2005 to that in 2007?
Your answer should be very brief. 0.85. What is the ratio of the Persistence rate to the last grade of primary education (%) of Nigeria in 2005 to that in 2007?
Your answer should be compact. 1.76. What is the ratio of the Persistence rate to the last grade of primary education (%) in Europe(all income levels) in 2005 to that in 2008?
Provide a short and direct response. 1.01. What is the ratio of the Persistence rate to the last grade of primary education (%) of Sub-Saharan Africa (developing only) in 2005 to that in 2008?
Give a very brief answer. 1.06. What is the ratio of the Persistence rate to the last grade of primary education (%) of Madagascar in 2005 to that in 2008?
Ensure brevity in your answer.  0.73. What is the ratio of the Persistence rate to the last grade of primary education (%) in Nigeria in 2005 to that in 2008?
Ensure brevity in your answer.  1.01. What is the ratio of the Persistence rate to the last grade of primary education (%) in Europe(all income levels) in 2005 to that in 2009?
Provide a short and direct response. 1. What is the ratio of the Persistence rate to the last grade of primary education (%) of Sub-Saharan Africa (developing only) in 2005 to that in 2009?
Provide a succinct answer. 1.09. What is the ratio of the Persistence rate to the last grade of primary education (%) of Madagascar in 2005 to that in 2009?
Your response must be concise. 1.04. What is the ratio of the Persistence rate to the last grade of primary education (%) of Nigeria in 2005 to that in 2009?
Provide a succinct answer. 0.98. What is the ratio of the Persistence rate to the last grade of primary education (%) of Sub-Saharan Africa (developing only) in 2006 to that in 2007?
Provide a succinct answer. 1.03. What is the ratio of the Persistence rate to the last grade of primary education (%) of Madagascar in 2006 to that in 2007?
Provide a succinct answer. 1. What is the ratio of the Persistence rate to the last grade of primary education (%) in Nigeria in 2006 to that in 2007?
Offer a very short reply. 1.11. What is the ratio of the Persistence rate to the last grade of primary education (%) of Europe(all income levels) in 2006 to that in 2008?
Make the answer very short. 1.01. What is the ratio of the Persistence rate to the last grade of primary education (%) of Sub-Saharan Africa (developing only) in 2006 to that in 2008?
Give a very brief answer. 0.98. What is the ratio of the Persistence rate to the last grade of primary education (%) of Nigeria in 2006 to that in 2008?
Your answer should be very brief. 0.64. What is the ratio of the Persistence rate to the last grade of primary education (%) in Madagascar in 2006 to that in 2009?
Your answer should be compact. 1.22. What is the ratio of the Persistence rate to the last grade of primary education (%) in Nigeria in 2006 to that in 2009?
Ensure brevity in your answer.  0.61. What is the ratio of the Persistence rate to the last grade of primary education (%) of Sub-Saharan Africa (developing only) in 2007 to that in 2008?
Make the answer very short. 0.95. What is the ratio of the Persistence rate to the last grade of primary education (%) in Madagascar in 2007 to that in 2008?
Provide a succinct answer. 0.86. What is the ratio of the Persistence rate to the last grade of primary education (%) of Nigeria in 2007 to that in 2008?
Provide a succinct answer. 0.57. What is the ratio of the Persistence rate to the last grade of primary education (%) of Europe(all income levels) in 2007 to that in 2009?
Make the answer very short. 0.99. What is the ratio of the Persistence rate to the last grade of primary education (%) in Madagascar in 2007 to that in 2009?
Offer a very short reply. 1.22. What is the ratio of the Persistence rate to the last grade of primary education (%) in Nigeria in 2007 to that in 2009?
Ensure brevity in your answer.  0.55. What is the ratio of the Persistence rate to the last grade of primary education (%) in Europe(all income levels) in 2008 to that in 2009?
Provide a short and direct response. 0.99. What is the ratio of the Persistence rate to the last grade of primary education (%) of Sub-Saharan Africa (developing only) in 2008 to that in 2009?
Ensure brevity in your answer.  1.02. What is the ratio of the Persistence rate to the last grade of primary education (%) in Madagascar in 2008 to that in 2009?
Your answer should be compact. 1.42. What is the ratio of the Persistence rate to the last grade of primary education (%) in Nigeria in 2008 to that in 2009?
Provide a short and direct response. 0.97. What is the difference between the highest and the second highest Persistence rate to the last grade of primary education (%) in Europe(all income levels)?
Provide a succinct answer. 0.21. What is the difference between the highest and the second highest Persistence rate to the last grade of primary education (%) of Sub-Saharan Africa (developing only)?
Make the answer very short. 1.26. What is the difference between the highest and the second highest Persistence rate to the last grade of primary education (%) in Madagascar?
Offer a very short reply. 7.11. What is the difference between the highest and the second highest Persistence rate to the last grade of primary education (%) of Nigeria?
Your answer should be very brief. 1.84. What is the difference between the highest and the lowest Persistence rate to the last grade of primary education (%) in Europe(all income levels)?
Your response must be concise. 1.02. What is the difference between the highest and the lowest Persistence rate to the last grade of primary education (%) in Sub-Saharan Africa (developing only)?
Your response must be concise. 6.71. What is the difference between the highest and the lowest Persistence rate to the last grade of primary education (%) of Madagascar?
Your answer should be compact. 15.02. What is the difference between the highest and the lowest Persistence rate to the last grade of primary education (%) in Nigeria?
Give a very brief answer. 36.66. 